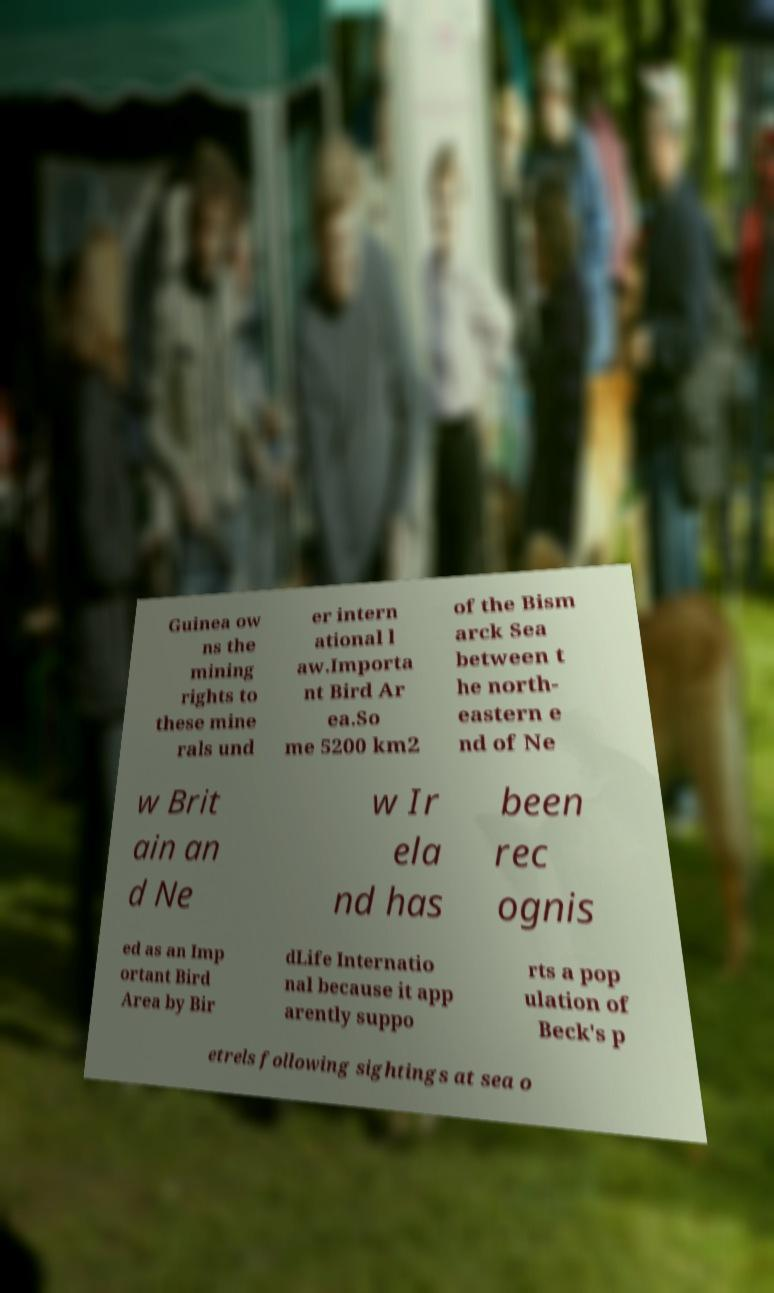Can you accurately transcribe the text from the provided image for me? Guinea ow ns the mining rights to these mine rals und er intern ational l aw.Importa nt Bird Ar ea.So me 5200 km2 of the Bism arck Sea between t he north- eastern e nd of Ne w Brit ain an d Ne w Ir ela nd has been rec ognis ed as an Imp ortant Bird Area by Bir dLife Internatio nal because it app arently suppo rts a pop ulation of Beck's p etrels following sightings at sea o 